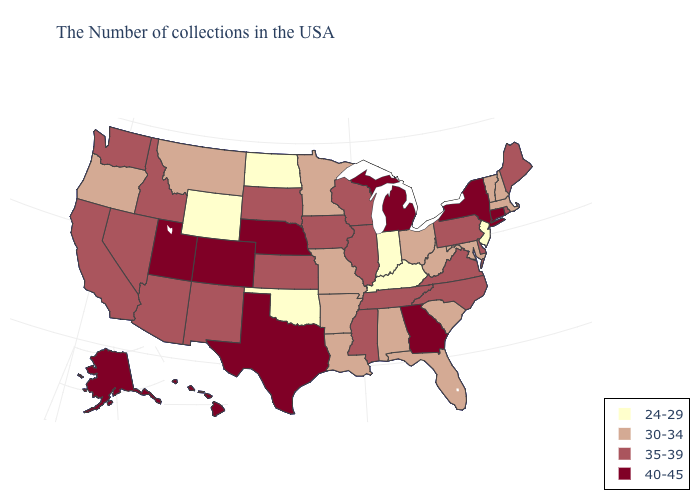Among the states that border Minnesota , does North Dakota have the lowest value?
Be succinct. Yes. Name the states that have a value in the range 35-39?
Give a very brief answer. Maine, Rhode Island, Delaware, Pennsylvania, Virginia, North Carolina, Tennessee, Wisconsin, Illinois, Mississippi, Iowa, Kansas, South Dakota, New Mexico, Arizona, Idaho, Nevada, California, Washington. What is the lowest value in the South?
Answer briefly. 24-29. Among the states that border South Dakota , does Iowa have the highest value?
Give a very brief answer. No. Among the states that border Wisconsin , which have the highest value?
Answer briefly. Michigan. Does the map have missing data?
Keep it brief. No. Which states have the lowest value in the Northeast?
Write a very short answer. New Jersey. How many symbols are there in the legend?
Concise answer only. 4. Does Hawaii have the lowest value in the West?
Answer briefly. No. Name the states that have a value in the range 24-29?
Answer briefly. New Jersey, Kentucky, Indiana, Oklahoma, North Dakota, Wyoming. What is the highest value in states that border Tennessee?
Short answer required. 40-45. Is the legend a continuous bar?
Be succinct. No. Name the states that have a value in the range 40-45?
Quick response, please. Connecticut, New York, Georgia, Michigan, Nebraska, Texas, Colorado, Utah, Alaska, Hawaii. Does Texas have the lowest value in the South?
Give a very brief answer. No. What is the highest value in the USA?
Short answer required. 40-45. 